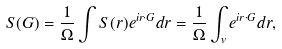Convert formula to latex. <formula><loc_0><loc_0><loc_500><loc_500>S ( G ) = \frac { 1 } { \Omega } \int S ( r ) e ^ { i r \cdot G } d r = \frac { 1 } { \Omega } \int _ { v } e ^ { i r \cdot G } d r ,</formula> 